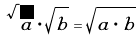Convert formula to latex. <formula><loc_0><loc_0><loc_500><loc_500>\sqrt { a } \cdot \sqrt { b } = \sqrt { a \cdot b }</formula> 